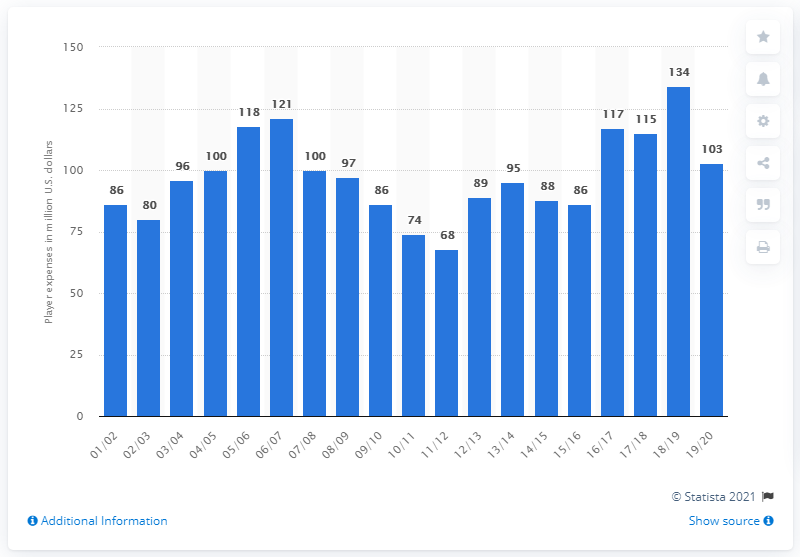Identify some key points in this picture. The player salary of the New York Knicks during the 2019/20 season was 103. 